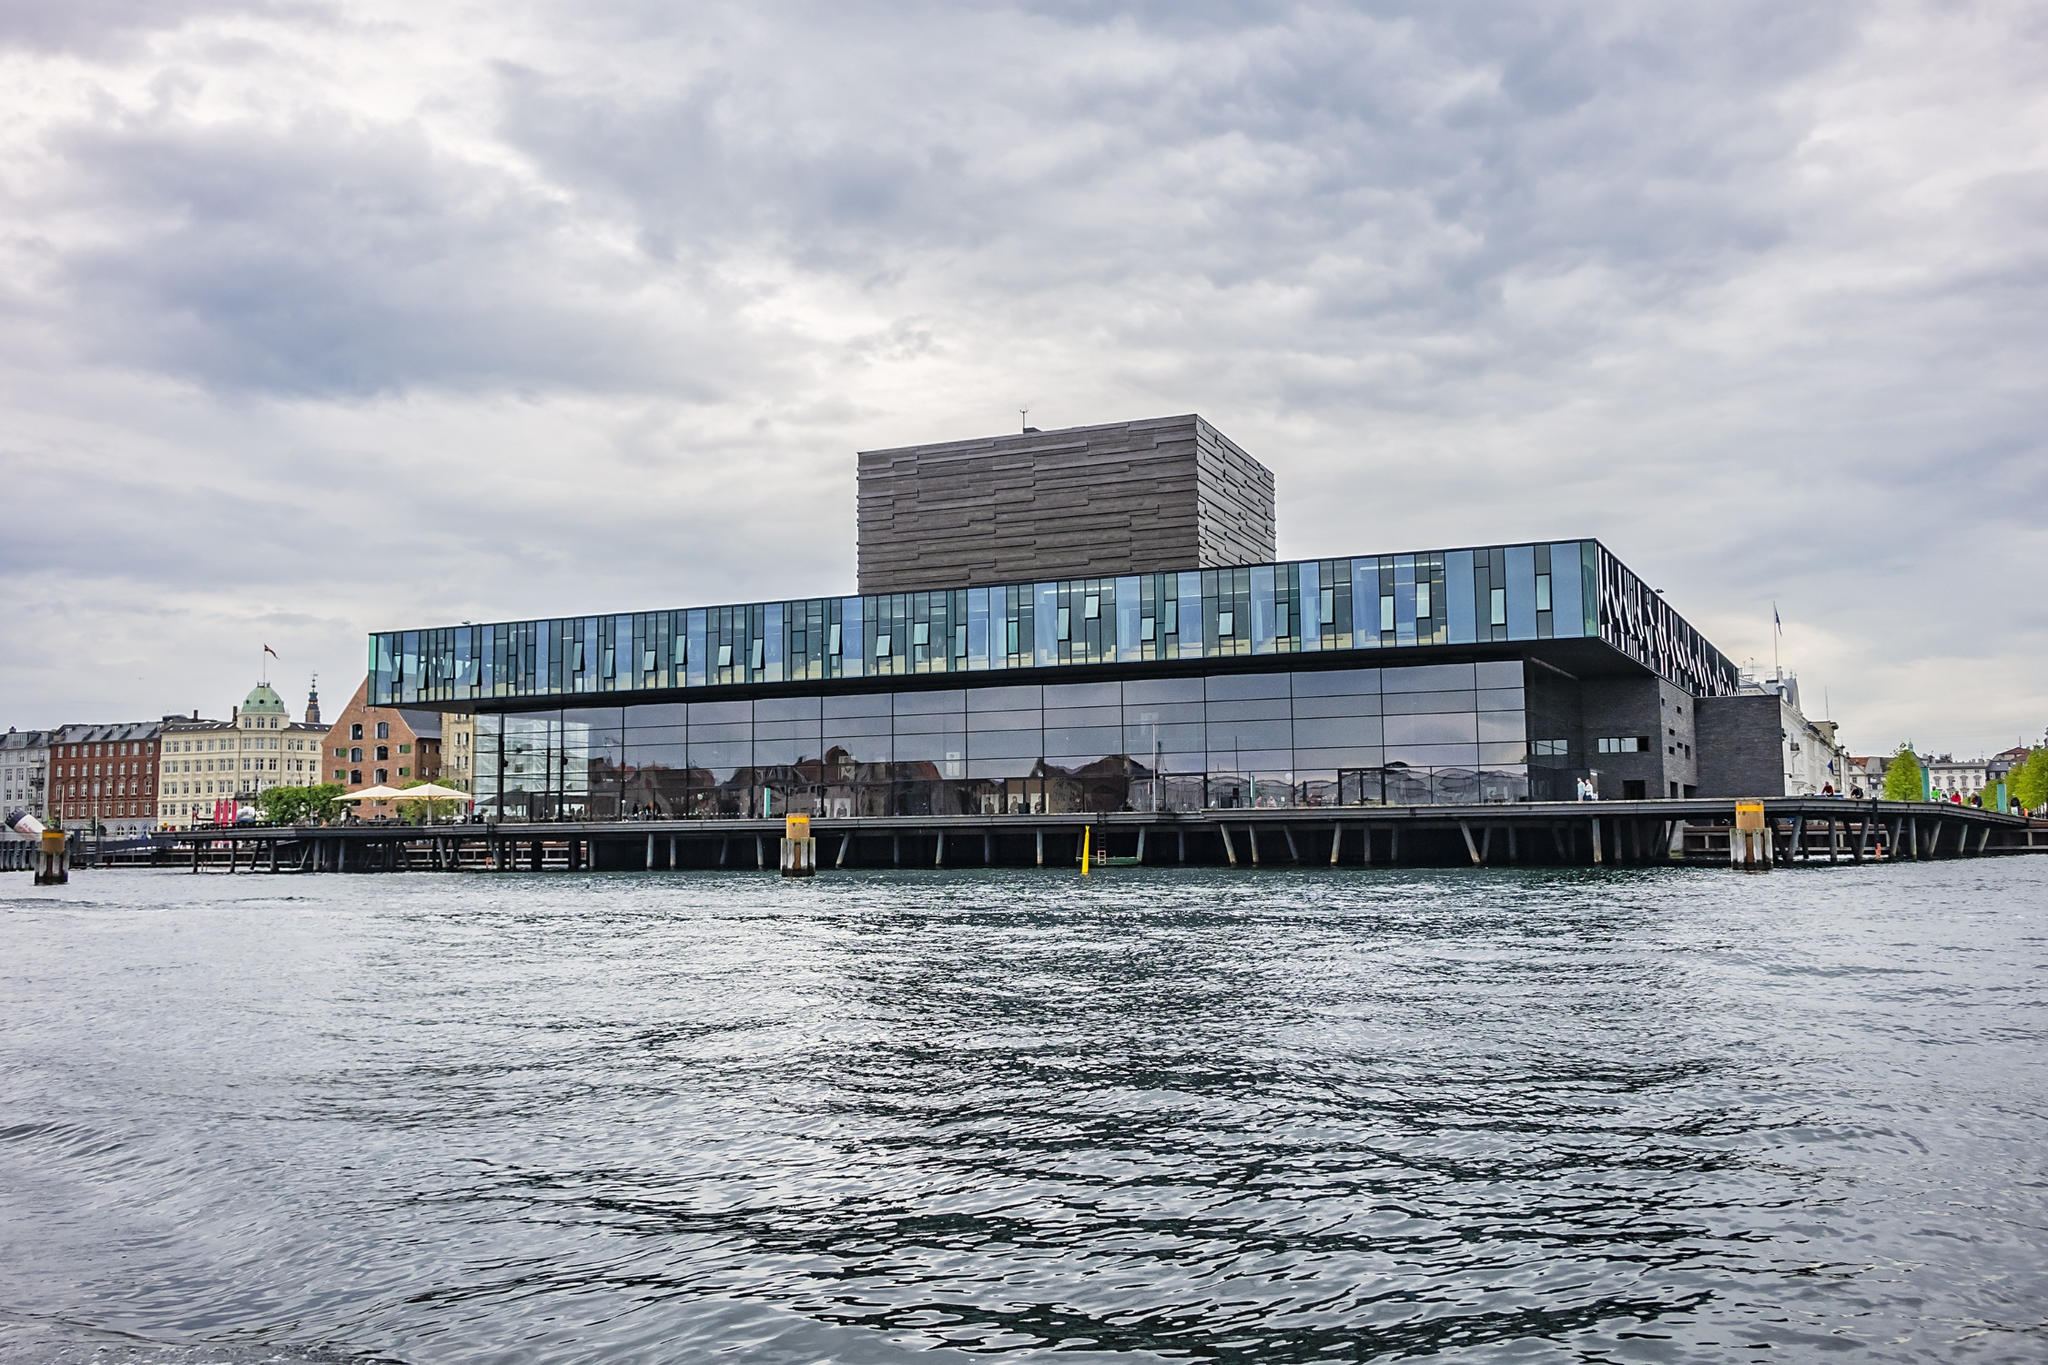What events or performances is the Royal Danish Playhouse known for hosting? The Royal Danish Playhouse is renowned for hosting a wide array of performances ranging from classical plays to modern dramas and musical performances. It serves as a hub for Danish cultural expression, featuring works by renowned local and international playwrights. The playhouse often holds events and festivals that highlight the richness of Denmark's theatrical tradition, offering audiences a deep dive into the world of performing arts, set within its visually striking and acoustically refined halls. 